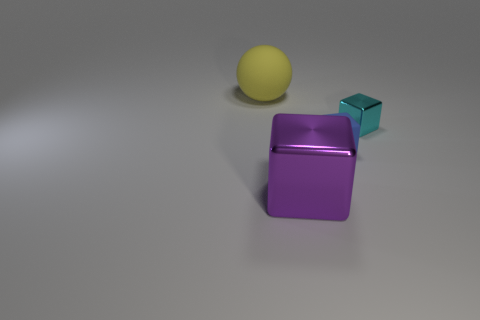How many big balls are the same color as the matte cube?
Offer a terse response. 0. There is a rubber thing that is on the right side of the rubber object behind the blue cube; how big is it?
Your answer should be very brief. Small. What is the shape of the blue matte thing?
Your response must be concise. Cube. What is the tiny cube that is behind the small blue matte cube made of?
Your answer should be compact. Metal. What is the color of the small object that is on the left side of the metal cube behind the object that is in front of the tiny blue cube?
Keep it short and to the point. Blue. There is a rubber cube that is the same size as the cyan shiny block; what is its color?
Make the answer very short. Blue. How many rubber objects are big balls or big purple cylinders?
Your response must be concise. 1. What color is the large thing that is made of the same material as the tiny blue cube?
Give a very brief answer. Yellow. There is a large thing that is right of the large thing behind the big cube; what is its material?
Your answer should be very brief. Metal. How many things are tiny things that are left of the small cyan metal cube or rubber things right of the large purple cube?
Your answer should be compact. 1. 